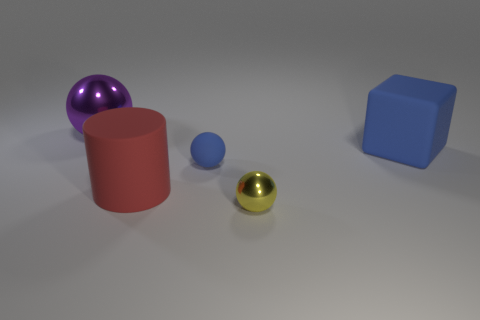Add 4 big brown blocks. How many objects exist? 9 Subtract all spheres. How many objects are left? 2 Subtract all tiny gray metallic blocks. Subtract all small blue things. How many objects are left? 4 Add 3 metal objects. How many metal objects are left? 5 Add 5 big brown matte cylinders. How many big brown matte cylinders exist? 5 Subtract 0 brown cylinders. How many objects are left? 5 